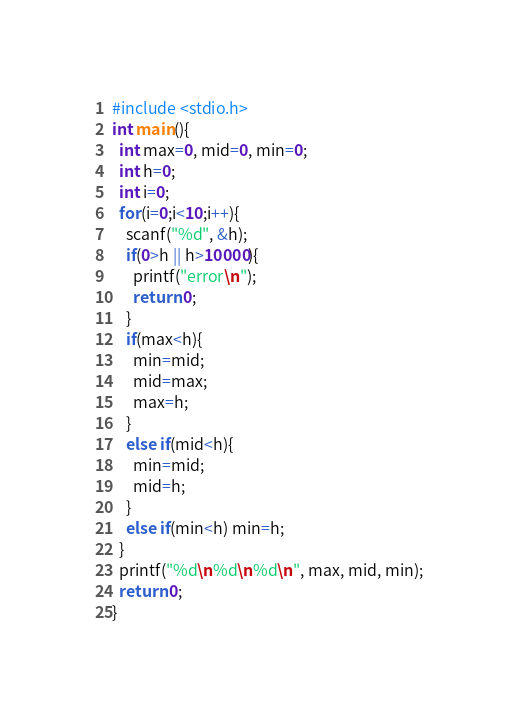Convert code to text. <code><loc_0><loc_0><loc_500><loc_500><_C_>#include <stdio.h>
int main(){
  int max=0, mid=0, min=0;
  int h=0;
  int i=0;
  for(i=0;i<10;i++){
    scanf("%d", &h);
    if(0>h || h>10000){
      printf("error\n");
      return 0;
    }
    if(max<h){
      min=mid;
      mid=max;
      max=h;
    }
    else if(mid<h){
      min=mid;
      mid=h;
    }
    else if(min<h) min=h;
  }
  printf("%d\n%d\n%d\n", max, mid, min);
  return 0;
}</code> 